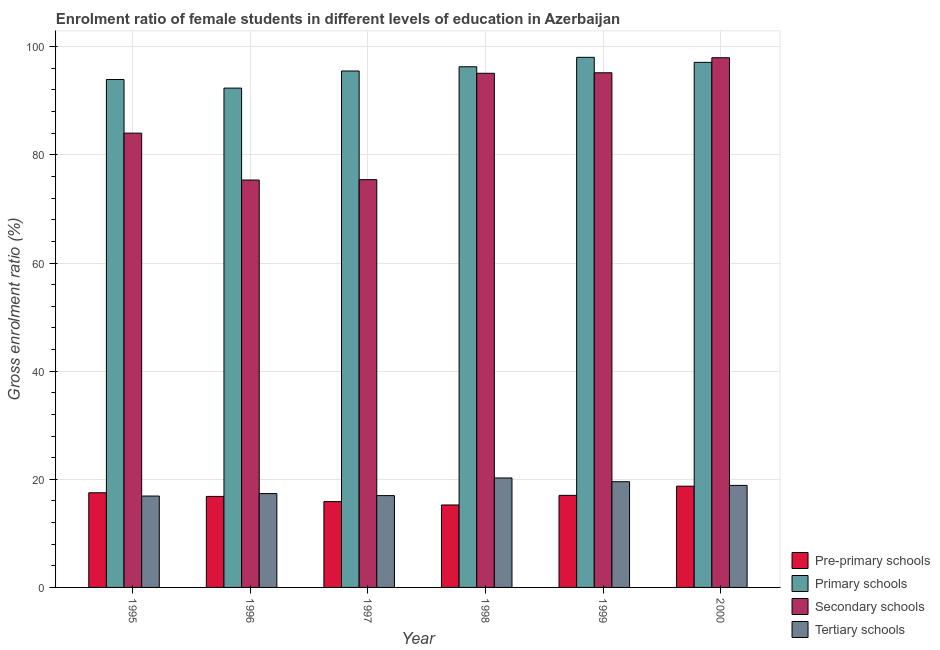How many different coloured bars are there?
Ensure brevity in your answer.  4. Are the number of bars per tick equal to the number of legend labels?
Keep it short and to the point. Yes. Are the number of bars on each tick of the X-axis equal?
Offer a terse response. Yes. How many bars are there on the 3rd tick from the right?
Give a very brief answer. 4. What is the gross enrolment ratio(male) in tertiary schools in 1996?
Provide a short and direct response. 17.35. Across all years, what is the maximum gross enrolment ratio(male) in pre-primary schools?
Ensure brevity in your answer.  18.72. Across all years, what is the minimum gross enrolment ratio(male) in pre-primary schools?
Offer a terse response. 15.25. In which year was the gross enrolment ratio(male) in tertiary schools maximum?
Provide a succinct answer. 1998. In which year was the gross enrolment ratio(male) in primary schools minimum?
Provide a short and direct response. 1996. What is the total gross enrolment ratio(male) in tertiary schools in the graph?
Ensure brevity in your answer.  109.9. What is the difference between the gross enrolment ratio(male) in secondary schools in 1996 and that in 1998?
Provide a short and direct response. -19.74. What is the difference between the gross enrolment ratio(male) in tertiary schools in 1998 and the gross enrolment ratio(male) in secondary schools in 1996?
Make the answer very short. 2.89. What is the average gross enrolment ratio(male) in pre-primary schools per year?
Your answer should be very brief. 16.87. In the year 1997, what is the difference between the gross enrolment ratio(male) in pre-primary schools and gross enrolment ratio(male) in primary schools?
Offer a terse response. 0. What is the ratio of the gross enrolment ratio(male) in secondary schools in 1998 to that in 1999?
Give a very brief answer. 1. Is the difference between the gross enrolment ratio(male) in secondary schools in 1995 and 2000 greater than the difference between the gross enrolment ratio(male) in primary schools in 1995 and 2000?
Your answer should be very brief. No. What is the difference between the highest and the second highest gross enrolment ratio(male) in primary schools?
Ensure brevity in your answer.  0.93. What is the difference between the highest and the lowest gross enrolment ratio(male) in secondary schools?
Offer a very short reply. 22.62. Is the sum of the gross enrolment ratio(male) in primary schools in 1995 and 2000 greater than the maximum gross enrolment ratio(male) in pre-primary schools across all years?
Offer a terse response. Yes. What does the 3rd bar from the left in 1997 represents?
Give a very brief answer. Secondary schools. What does the 3rd bar from the right in 2000 represents?
Your response must be concise. Primary schools. How many years are there in the graph?
Provide a succinct answer. 6. What is the difference between two consecutive major ticks on the Y-axis?
Offer a terse response. 20. Does the graph contain grids?
Ensure brevity in your answer.  Yes. Where does the legend appear in the graph?
Your answer should be compact. Bottom right. How many legend labels are there?
Offer a terse response. 4. How are the legend labels stacked?
Make the answer very short. Vertical. What is the title of the graph?
Your response must be concise. Enrolment ratio of female students in different levels of education in Azerbaijan. Does "Self-employed" appear as one of the legend labels in the graph?
Offer a terse response. No. What is the Gross enrolment ratio (%) of Pre-primary schools in 1995?
Your answer should be very brief. 17.51. What is the Gross enrolment ratio (%) in Primary schools in 1995?
Your answer should be compact. 93.93. What is the Gross enrolment ratio (%) of Secondary schools in 1995?
Provide a succinct answer. 84.02. What is the Gross enrolment ratio (%) in Tertiary schools in 1995?
Offer a terse response. 16.9. What is the Gross enrolment ratio (%) of Pre-primary schools in 1996?
Your answer should be very brief. 16.83. What is the Gross enrolment ratio (%) of Primary schools in 1996?
Offer a terse response. 92.35. What is the Gross enrolment ratio (%) in Secondary schools in 1996?
Offer a terse response. 75.35. What is the Gross enrolment ratio (%) of Tertiary schools in 1996?
Provide a short and direct response. 17.35. What is the Gross enrolment ratio (%) in Pre-primary schools in 1997?
Offer a terse response. 15.87. What is the Gross enrolment ratio (%) of Primary schools in 1997?
Keep it short and to the point. 95.51. What is the Gross enrolment ratio (%) of Secondary schools in 1997?
Make the answer very short. 75.41. What is the Gross enrolment ratio (%) of Tertiary schools in 1997?
Offer a very short reply. 16.98. What is the Gross enrolment ratio (%) of Pre-primary schools in 1998?
Your answer should be very brief. 15.25. What is the Gross enrolment ratio (%) in Primary schools in 1998?
Give a very brief answer. 96.29. What is the Gross enrolment ratio (%) in Secondary schools in 1998?
Provide a short and direct response. 95.09. What is the Gross enrolment ratio (%) in Tertiary schools in 1998?
Your response must be concise. 20.25. What is the Gross enrolment ratio (%) in Pre-primary schools in 1999?
Your answer should be very brief. 17.02. What is the Gross enrolment ratio (%) in Primary schools in 1999?
Ensure brevity in your answer.  98.04. What is the Gross enrolment ratio (%) in Secondary schools in 1999?
Ensure brevity in your answer.  95.18. What is the Gross enrolment ratio (%) in Tertiary schools in 1999?
Give a very brief answer. 19.55. What is the Gross enrolment ratio (%) in Pre-primary schools in 2000?
Provide a succinct answer. 18.72. What is the Gross enrolment ratio (%) of Primary schools in 2000?
Make the answer very short. 97.11. What is the Gross enrolment ratio (%) of Secondary schools in 2000?
Ensure brevity in your answer.  97.96. What is the Gross enrolment ratio (%) of Tertiary schools in 2000?
Give a very brief answer. 18.87. Across all years, what is the maximum Gross enrolment ratio (%) in Pre-primary schools?
Make the answer very short. 18.72. Across all years, what is the maximum Gross enrolment ratio (%) of Primary schools?
Your response must be concise. 98.04. Across all years, what is the maximum Gross enrolment ratio (%) of Secondary schools?
Provide a succinct answer. 97.96. Across all years, what is the maximum Gross enrolment ratio (%) of Tertiary schools?
Provide a succinct answer. 20.25. Across all years, what is the minimum Gross enrolment ratio (%) of Pre-primary schools?
Keep it short and to the point. 15.25. Across all years, what is the minimum Gross enrolment ratio (%) of Primary schools?
Provide a succinct answer. 92.35. Across all years, what is the minimum Gross enrolment ratio (%) in Secondary schools?
Provide a short and direct response. 75.35. Across all years, what is the minimum Gross enrolment ratio (%) in Tertiary schools?
Your answer should be compact. 16.9. What is the total Gross enrolment ratio (%) in Pre-primary schools in the graph?
Make the answer very short. 101.21. What is the total Gross enrolment ratio (%) of Primary schools in the graph?
Make the answer very short. 573.23. What is the total Gross enrolment ratio (%) of Secondary schools in the graph?
Your response must be concise. 523.01. What is the total Gross enrolment ratio (%) in Tertiary schools in the graph?
Your answer should be very brief. 109.9. What is the difference between the Gross enrolment ratio (%) of Pre-primary schools in 1995 and that in 1996?
Your response must be concise. 0.68. What is the difference between the Gross enrolment ratio (%) in Primary schools in 1995 and that in 1996?
Give a very brief answer. 1.59. What is the difference between the Gross enrolment ratio (%) of Secondary schools in 1995 and that in 1996?
Provide a succinct answer. 8.67. What is the difference between the Gross enrolment ratio (%) of Tertiary schools in 1995 and that in 1996?
Ensure brevity in your answer.  -0.45. What is the difference between the Gross enrolment ratio (%) in Pre-primary schools in 1995 and that in 1997?
Your answer should be compact. 1.64. What is the difference between the Gross enrolment ratio (%) in Primary schools in 1995 and that in 1997?
Your answer should be compact. -1.58. What is the difference between the Gross enrolment ratio (%) of Secondary schools in 1995 and that in 1997?
Make the answer very short. 8.61. What is the difference between the Gross enrolment ratio (%) in Tertiary schools in 1995 and that in 1997?
Make the answer very short. -0.08. What is the difference between the Gross enrolment ratio (%) in Pre-primary schools in 1995 and that in 1998?
Offer a very short reply. 2.26. What is the difference between the Gross enrolment ratio (%) of Primary schools in 1995 and that in 1998?
Ensure brevity in your answer.  -2.36. What is the difference between the Gross enrolment ratio (%) in Secondary schools in 1995 and that in 1998?
Ensure brevity in your answer.  -11.07. What is the difference between the Gross enrolment ratio (%) in Tertiary schools in 1995 and that in 1998?
Offer a terse response. -3.34. What is the difference between the Gross enrolment ratio (%) in Pre-primary schools in 1995 and that in 1999?
Offer a terse response. 0.48. What is the difference between the Gross enrolment ratio (%) of Primary schools in 1995 and that in 1999?
Give a very brief answer. -4.1. What is the difference between the Gross enrolment ratio (%) in Secondary schools in 1995 and that in 1999?
Ensure brevity in your answer.  -11.16. What is the difference between the Gross enrolment ratio (%) of Tertiary schools in 1995 and that in 1999?
Your response must be concise. -2.65. What is the difference between the Gross enrolment ratio (%) of Pre-primary schools in 1995 and that in 2000?
Your answer should be very brief. -1.22. What is the difference between the Gross enrolment ratio (%) of Primary schools in 1995 and that in 2000?
Provide a short and direct response. -3.17. What is the difference between the Gross enrolment ratio (%) in Secondary schools in 1995 and that in 2000?
Offer a terse response. -13.95. What is the difference between the Gross enrolment ratio (%) in Tertiary schools in 1995 and that in 2000?
Your answer should be compact. -1.97. What is the difference between the Gross enrolment ratio (%) of Pre-primary schools in 1996 and that in 1997?
Offer a terse response. 0.96. What is the difference between the Gross enrolment ratio (%) in Primary schools in 1996 and that in 1997?
Provide a succinct answer. -3.16. What is the difference between the Gross enrolment ratio (%) in Secondary schools in 1996 and that in 1997?
Provide a succinct answer. -0.07. What is the difference between the Gross enrolment ratio (%) in Tertiary schools in 1996 and that in 1997?
Your response must be concise. 0.37. What is the difference between the Gross enrolment ratio (%) in Pre-primary schools in 1996 and that in 1998?
Give a very brief answer. 1.58. What is the difference between the Gross enrolment ratio (%) in Primary schools in 1996 and that in 1998?
Make the answer very short. -3.95. What is the difference between the Gross enrolment ratio (%) in Secondary schools in 1996 and that in 1998?
Your response must be concise. -19.74. What is the difference between the Gross enrolment ratio (%) in Tertiary schools in 1996 and that in 1998?
Make the answer very short. -2.89. What is the difference between the Gross enrolment ratio (%) of Pre-primary schools in 1996 and that in 1999?
Offer a terse response. -0.19. What is the difference between the Gross enrolment ratio (%) in Primary schools in 1996 and that in 1999?
Give a very brief answer. -5.69. What is the difference between the Gross enrolment ratio (%) in Secondary schools in 1996 and that in 1999?
Give a very brief answer. -19.84. What is the difference between the Gross enrolment ratio (%) in Tertiary schools in 1996 and that in 1999?
Provide a succinct answer. -2.2. What is the difference between the Gross enrolment ratio (%) in Pre-primary schools in 1996 and that in 2000?
Your answer should be very brief. -1.89. What is the difference between the Gross enrolment ratio (%) in Primary schools in 1996 and that in 2000?
Provide a short and direct response. -4.76. What is the difference between the Gross enrolment ratio (%) in Secondary schools in 1996 and that in 2000?
Your answer should be compact. -22.62. What is the difference between the Gross enrolment ratio (%) in Tertiary schools in 1996 and that in 2000?
Make the answer very short. -1.52. What is the difference between the Gross enrolment ratio (%) in Pre-primary schools in 1997 and that in 1998?
Provide a succinct answer. 0.62. What is the difference between the Gross enrolment ratio (%) of Primary schools in 1997 and that in 1998?
Your answer should be compact. -0.78. What is the difference between the Gross enrolment ratio (%) of Secondary schools in 1997 and that in 1998?
Make the answer very short. -19.67. What is the difference between the Gross enrolment ratio (%) of Tertiary schools in 1997 and that in 1998?
Make the answer very short. -3.26. What is the difference between the Gross enrolment ratio (%) in Pre-primary schools in 1997 and that in 1999?
Your answer should be compact. -1.15. What is the difference between the Gross enrolment ratio (%) in Primary schools in 1997 and that in 1999?
Keep it short and to the point. -2.53. What is the difference between the Gross enrolment ratio (%) in Secondary schools in 1997 and that in 1999?
Make the answer very short. -19.77. What is the difference between the Gross enrolment ratio (%) of Tertiary schools in 1997 and that in 1999?
Your answer should be very brief. -2.57. What is the difference between the Gross enrolment ratio (%) in Pre-primary schools in 1997 and that in 2000?
Offer a terse response. -2.85. What is the difference between the Gross enrolment ratio (%) in Primary schools in 1997 and that in 2000?
Make the answer very short. -1.6. What is the difference between the Gross enrolment ratio (%) of Secondary schools in 1997 and that in 2000?
Ensure brevity in your answer.  -22.55. What is the difference between the Gross enrolment ratio (%) in Tertiary schools in 1997 and that in 2000?
Your answer should be very brief. -1.89. What is the difference between the Gross enrolment ratio (%) of Pre-primary schools in 1998 and that in 1999?
Offer a very short reply. -1.78. What is the difference between the Gross enrolment ratio (%) of Primary schools in 1998 and that in 1999?
Keep it short and to the point. -1.74. What is the difference between the Gross enrolment ratio (%) in Secondary schools in 1998 and that in 1999?
Give a very brief answer. -0.1. What is the difference between the Gross enrolment ratio (%) of Tertiary schools in 1998 and that in 1999?
Make the answer very short. 0.7. What is the difference between the Gross enrolment ratio (%) in Pre-primary schools in 1998 and that in 2000?
Provide a succinct answer. -3.48. What is the difference between the Gross enrolment ratio (%) in Primary schools in 1998 and that in 2000?
Make the answer very short. -0.81. What is the difference between the Gross enrolment ratio (%) of Secondary schools in 1998 and that in 2000?
Keep it short and to the point. -2.88. What is the difference between the Gross enrolment ratio (%) in Tertiary schools in 1998 and that in 2000?
Provide a succinct answer. 1.38. What is the difference between the Gross enrolment ratio (%) of Pre-primary schools in 1999 and that in 2000?
Ensure brevity in your answer.  -1.7. What is the difference between the Gross enrolment ratio (%) of Secondary schools in 1999 and that in 2000?
Provide a short and direct response. -2.78. What is the difference between the Gross enrolment ratio (%) in Tertiary schools in 1999 and that in 2000?
Offer a very short reply. 0.68. What is the difference between the Gross enrolment ratio (%) of Pre-primary schools in 1995 and the Gross enrolment ratio (%) of Primary schools in 1996?
Offer a very short reply. -74.84. What is the difference between the Gross enrolment ratio (%) of Pre-primary schools in 1995 and the Gross enrolment ratio (%) of Secondary schools in 1996?
Ensure brevity in your answer.  -57.84. What is the difference between the Gross enrolment ratio (%) in Pre-primary schools in 1995 and the Gross enrolment ratio (%) in Tertiary schools in 1996?
Ensure brevity in your answer.  0.15. What is the difference between the Gross enrolment ratio (%) of Primary schools in 1995 and the Gross enrolment ratio (%) of Secondary schools in 1996?
Ensure brevity in your answer.  18.59. What is the difference between the Gross enrolment ratio (%) of Primary schools in 1995 and the Gross enrolment ratio (%) of Tertiary schools in 1996?
Offer a very short reply. 76.58. What is the difference between the Gross enrolment ratio (%) in Secondary schools in 1995 and the Gross enrolment ratio (%) in Tertiary schools in 1996?
Ensure brevity in your answer.  66.67. What is the difference between the Gross enrolment ratio (%) of Pre-primary schools in 1995 and the Gross enrolment ratio (%) of Primary schools in 1997?
Provide a short and direct response. -78. What is the difference between the Gross enrolment ratio (%) of Pre-primary schools in 1995 and the Gross enrolment ratio (%) of Secondary schools in 1997?
Provide a short and direct response. -57.9. What is the difference between the Gross enrolment ratio (%) in Pre-primary schools in 1995 and the Gross enrolment ratio (%) in Tertiary schools in 1997?
Offer a terse response. 0.53. What is the difference between the Gross enrolment ratio (%) of Primary schools in 1995 and the Gross enrolment ratio (%) of Secondary schools in 1997?
Provide a short and direct response. 18.52. What is the difference between the Gross enrolment ratio (%) of Primary schools in 1995 and the Gross enrolment ratio (%) of Tertiary schools in 1997?
Provide a short and direct response. 76.95. What is the difference between the Gross enrolment ratio (%) in Secondary schools in 1995 and the Gross enrolment ratio (%) in Tertiary schools in 1997?
Keep it short and to the point. 67.04. What is the difference between the Gross enrolment ratio (%) in Pre-primary schools in 1995 and the Gross enrolment ratio (%) in Primary schools in 1998?
Give a very brief answer. -78.79. What is the difference between the Gross enrolment ratio (%) in Pre-primary schools in 1995 and the Gross enrolment ratio (%) in Secondary schools in 1998?
Offer a very short reply. -77.58. What is the difference between the Gross enrolment ratio (%) in Pre-primary schools in 1995 and the Gross enrolment ratio (%) in Tertiary schools in 1998?
Offer a terse response. -2.74. What is the difference between the Gross enrolment ratio (%) in Primary schools in 1995 and the Gross enrolment ratio (%) in Secondary schools in 1998?
Offer a terse response. -1.15. What is the difference between the Gross enrolment ratio (%) in Primary schools in 1995 and the Gross enrolment ratio (%) in Tertiary schools in 1998?
Give a very brief answer. 73.69. What is the difference between the Gross enrolment ratio (%) of Secondary schools in 1995 and the Gross enrolment ratio (%) of Tertiary schools in 1998?
Offer a very short reply. 63.77. What is the difference between the Gross enrolment ratio (%) of Pre-primary schools in 1995 and the Gross enrolment ratio (%) of Primary schools in 1999?
Give a very brief answer. -80.53. What is the difference between the Gross enrolment ratio (%) of Pre-primary schools in 1995 and the Gross enrolment ratio (%) of Secondary schools in 1999?
Your response must be concise. -77.67. What is the difference between the Gross enrolment ratio (%) of Pre-primary schools in 1995 and the Gross enrolment ratio (%) of Tertiary schools in 1999?
Keep it short and to the point. -2.04. What is the difference between the Gross enrolment ratio (%) in Primary schools in 1995 and the Gross enrolment ratio (%) in Secondary schools in 1999?
Offer a terse response. -1.25. What is the difference between the Gross enrolment ratio (%) in Primary schools in 1995 and the Gross enrolment ratio (%) in Tertiary schools in 1999?
Offer a very short reply. 74.38. What is the difference between the Gross enrolment ratio (%) of Secondary schools in 1995 and the Gross enrolment ratio (%) of Tertiary schools in 1999?
Offer a terse response. 64.47. What is the difference between the Gross enrolment ratio (%) in Pre-primary schools in 1995 and the Gross enrolment ratio (%) in Primary schools in 2000?
Provide a succinct answer. -79.6. What is the difference between the Gross enrolment ratio (%) in Pre-primary schools in 1995 and the Gross enrolment ratio (%) in Secondary schools in 2000?
Offer a very short reply. -80.46. What is the difference between the Gross enrolment ratio (%) of Pre-primary schools in 1995 and the Gross enrolment ratio (%) of Tertiary schools in 2000?
Your answer should be very brief. -1.36. What is the difference between the Gross enrolment ratio (%) in Primary schools in 1995 and the Gross enrolment ratio (%) in Secondary schools in 2000?
Make the answer very short. -4.03. What is the difference between the Gross enrolment ratio (%) in Primary schools in 1995 and the Gross enrolment ratio (%) in Tertiary schools in 2000?
Your answer should be compact. 75.06. What is the difference between the Gross enrolment ratio (%) in Secondary schools in 1995 and the Gross enrolment ratio (%) in Tertiary schools in 2000?
Make the answer very short. 65.15. What is the difference between the Gross enrolment ratio (%) of Pre-primary schools in 1996 and the Gross enrolment ratio (%) of Primary schools in 1997?
Your response must be concise. -78.68. What is the difference between the Gross enrolment ratio (%) of Pre-primary schools in 1996 and the Gross enrolment ratio (%) of Secondary schools in 1997?
Your answer should be compact. -58.58. What is the difference between the Gross enrolment ratio (%) of Pre-primary schools in 1996 and the Gross enrolment ratio (%) of Tertiary schools in 1997?
Your response must be concise. -0.15. What is the difference between the Gross enrolment ratio (%) of Primary schools in 1996 and the Gross enrolment ratio (%) of Secondary schools in 1997?
Offer a very short reply. 16.94. What is the difference between the Gross enrolment ratio (%) of Primary schools in 1996 and the Gross enrolment ratio (%) of Tertiary schools in 1997?
Your answer should be very brief. 75.37. What is the difference between the Gross enrolment ratio (%) in Secondary schools in 1996 and the Gross enrolment ratio (%) in Tertiary schools in 1997?
Offer a very short reply. 58.36. What is the difference between the Gross enrolment ratio (%) of Pre-primary schools in 1996 and the Gross enrolment ratio (%) of Primary schools in 1998?
Give a very brief answer. -79.46. What is the difference between the Gross enrolment ratio (%) of Pre-primary schools in 1996 and the Gross enrolment ratio (%) of Secondary schools in 1998?
Give a very brief answer. -78.25. What is the difference between the Gross enrolment ratio (%) in Pre-primary schools in 1996 and the Gross enrolment ratio (%) in Tertiary schools in 1998?
Provide a succinct answer. -3.41. What is the difference between the Gross enrolment ratio (%) of Primary schools in 1996 and the Gross enrolment ratio (%) of Secondary schools in 1998?
Your response must be concise. -2.74. What is the difference between the Gross enrolment ratio (%) in Primary schools in 1996 and the Gross enrolment ratio (%) in Tertiary schools in 1998?
Provide a short and direct response. 72.1. What is the difference between the Gross enrolment ratio (%) of Secondary schools in 1996 and the Gross enrolment ratio (%) of Tertiary schools in 1998?
Your response must be concise. 55.1. What is the difference between the Gross enrolment ratio (%) of Pre-primary schools in 1996 and the Gross enrolment ratio (%) of Primary schools in 1999?
Provide a short and direct response. -81.21. What is the difference between the Gross enrolment ratio (%) in Pre-primary schools in 1996 and the Gross enrolment ratio (%) in Secondary schools in 1999?
Your response must be concise. -78.35. What is the difference between the Gross enrolment ratio (%) of Pre-primary schools in 1996 and the Gross enrolment ratio (%) of Tertiary schools in 1999?
Your response must be concise. -2.72. What is the difference between the Gross enrolment ratio (%) in Primary schools in 1996 and the Gross enrolment ratio (%) in Secondary schools in 1999?
Your response must be concise. -2.83. What is the difference between the Gross enrolment ratio (%) in Primary schools in 1996 and the Gross enrolment ratio (%) in Tertiary schools in 1999?
Your answer should be very brief. 72.8. What is the difference between the Gross enrolment ratio (%) in Secondary schools in 1996 and the Gross enrolment ratio (%) in Tertiary schools in 1999?
Make the answer very short. 55.8. What is the difference between the Gross enrolment ratio (%) of Pre-primary schools in 1996 and the Gross enrolment ratio (%) of Primary schools in 2000?
Keep it short and to the point. -80.28. What is the difference between the Gross enrolment ratio (%) of Pre-primary schools in 1996 and the Gross enrolment ratio (%) of Secondary schools in 2000?
Offer a terse response. -81.13. What is the difference between the Gross enrolment ratio (%) of Pre-primary schools in 1996 and the Gross enrolment ratio (%) of Tertiary schools in 2000?
Provide a succinct answer. -2.04. What is the difference between the Gross enrolment ratio (%) in Primary schools in 1996 and the Gross enrolment ratio (%) in Secondary schools in 2000?
Provide a succinct answer. -5.62. What is the difference between the Gross enrolment ratio (%) of Primary schools in 1996 and the Gross enrolment ratio (%) of Tertiary schools in 2000?
Offer a terse response. 73.48. What is the difference between the Gross enrolment ratio (%) in Secondary schools in 1996 and the Gross enrolment ratio (%) in Tertiary schools in 2000?
Your response must be concise. 56.48. What is the difference between the Gross enrolment ratio (%) of Pre-primary schools in 1997 and the Gross enrolment ratio (%) of Primary schools in 1998?
Ensure brevity in your answer.  -80.42. What is the difference between the Gross enrolment ratio (%) of Pre-primary schools in 1997 and the Gross enrolment ratio (%) of Secondary schools in 1998?
Keep it short and to the point. -79.21. What is the difference between the Gross enrolment ratio (%) in Pre-primary schools in 1997 and the Gross enrolment ratio (%) in Tertiary schools in 1998?
Offer a very short reply. -4.37. What is the difference between the Gross enrolment ratio (%) of Primary schools in 1997 and the Gross enrolment ratio (%) of Secondary schools in 1998?
Offer a very short reply. 0.43. What is the difference between the Gross enrolment ratio (%) of Primary schools in 1997 and the Gross enrolment ratio (%) of Tertiary schools in 1998?
Your answer should be compact. 75.27. What is the difference between the Gross enrolment ratio (%) in Secondary schools in 1997 and the Gross enrolment ratio (%) in Tertiary schools in 1998?
Ensure brevity in your answer.  55.17. What is the difference between the Gross enrolment ratio (%) in Pre-primary schools in 1997 and the Gross enrolment ratio (%) in Primary schools in 1999?
Offer a very short reply. -82.17. What is the difference between the Gross enrolment ratio (%) of Pre-primary schools in 1997 and the Gross enrolment ratio (%) of Secondary schools in 1999?
Provide a short and direct response. -79.31. What is the difference between the Gross enrolment ratio (%) in Pre-primary schools in 1997 and the Gross enrolment ratio (%) in Tertiary schools in 1999?
Make the answer very short. -3.68. What is the difference between the Gross enrolment ratio (%) in Primary schools in 1997 and the Gross enrolment ratio (%) in Secondary schools in 1999?
Offer a very short reply. 0.33. What is the difference between the Gross enrolment ratio (%) in Primary schools in 1997 and the Gross enrolment ratio (%) in Tertiary schools in 1999?
Your answer should be compact. 75.96. What is the difference between the Gross enrolment ratio (%) in Secondary schools in 1997 and the Gross enrolment ratio (%) in Tertiary schools in 1999?
Ensure brevity in your answer.  55.86. What is the difference between the Gross enrolment ratio (%) in Pre-primary schools in 1997 and the Gross enrolment ratio (%) in Primary schools in 2000?
Provide a succinct answer. -81.24. What is the difference between the Gross enrolment ratio (%) in Pre-primary schools in 1997 and the Gross enrolment ratio (%) in Secondary schools in 2000?
Make the answer very short. -82.09. What is the difference between the Gross enrolment ratio (%) of Pre-primary schools in 1997 and the Gross enrolment ratio (%) of Tertiary schools in 2000?
Your answer should be compact. -3. What is the difference between the Gross enrolment ratio (%) of Primary schools in 1997 and the Gross enrolment ratio (%) of Secondary schools in 2000?
Offer a terse response. -2.45. What is the difference between the Gross enrolment ratio (%) in Primary schools in 1997 and the Gross enrolment ratio (%) in Tertiary schools in 2000?
Provide a short and direct response. 76.64. What is the difference between the Gross enrolment ratio (%) in Secondary schools in 1997 and the Gross enrolment ratio (%) in Tertiary schools in 2000?
Offer a terse response. 56.54. What is the difference between the Gross enrolment ratio (%) in Pre-primary schools in 1998 and the Gross enrolment ratio (%) in Primary schools in 1999?
Ensure brevity in your answer.  -82.79. What is the difference between the Gross enrolment ratio (%) in Pre-primary schools in 1998 and the Gross enrolment ratio (%) in Secondary schools in 1999?
Offer a terse response. -79.93. What is the difference between the Gross enrolment ratio (%) in Pre-primary schools in 1998 and the Gross enrolment ratio (%) in Tertiary schools in 1999?
Offer a terse response. -4.3. What is the difference between the Gross enrolment ratio (%) in Primary schools in 1998 and the Gross enrolment ratio (%) in Secondary schools in 1999?
Keep it short and to the point. 1.11. What is the difference between the Gross enrolment ratio (%) of Primary schools in 1998 and the Gross enrolment ratio (%) of Tertiary schools in 1999?
Provide a succinct answer. 76.74. What is the difference between the Gross enrolment ratio (%) of Secondary schools in 1998 and the Gross enrolment ratio (%) of Tertiary schools in 1999?
Offer a very short reply. 75.53. What is the difference between the Gross enrolment ratio (%) in Pre-primary schools in 1998 and the Gross enrolment ratio (%) in Primary schools in 2000?
Give a very brief answer. -81.86. What is the difference between the Gross enrolment ratio (%) of Pre-primary schools in 1998 and the Gross enrolment ratio (%) of Secondary schools in 2000?
Make the answer very short. -82.72. What is the difference between the Gross enrolment ratio (%) of Pre-primary schools in 1998 and the Gross enrolment ratio (%) of Tertiary schools in 2000?
Make the answer very short. -3.62. What is the difference between the Gross enrolment ratio (%) in Primary schools in 1998 and the Gross enrolment ratio (%) in Secondary schools in 2000?
Provide a succinct answer. -1.67. What is the difference between the Gross enrolment ratio (%) of Primary schools in 1998 and the Gross enrolment ratio (%) of Tertiary schools in 2000?
Your answer should be compact. 77.42. What is the difference between the Gross enrolment ratio (%) of Secondary schools in 1998 and the Gross enrolment ratio (%) of Tertiary schools in 2000?
Your response must be concise. 76.21. What is the difference between the Gross enrolment ratio (%) in Pre-primary schools in 1999 and the Gross enrolment ratio (%) in Primary schools in 2000?
Make the answer very short. -80.08. What is the difference between the Gross enrolment ratio (%) in Pre-primary schools in 1999 and the Gross enrolment ratio (%) in Secondary schools in 2000?
Provide a succinct answer. -80.94. What is the difference between the Gross enrolment ratio (%) in Pre-primary schools in 1999 and the Gross enrolment ratio (%) in Tertiary schools in 2000?
Offer a terse response. -1.85. What is the difference between the Gross enrolment ratio (%) of Primary schools in 1999 and the Gross enrolment ratio (%) of Secondary schools in 2000?
Your answer should be very brief. 0.07. What is the difference between the Gross enrolment ratio (%) of Primary schools in 1999 and the Gross enrolment ratio (%) of Tertiary schools in 2000?
Give a very brief answer. 79.17. What is the difference between the Gross enrolment ratio (%) in Secondary schools in 1999 and the Gross enrolment ratio (%) in Tertiary schools in 2000?
Make the answer very short. 76.31. What is the average Gross enrolment ratio (%) of Pre-primary schools per year?
Your answer should be compact. 16.87. What is the average Gross enrolment ratio (%) of Primary schools per year?
Provide a succinct answer. 95.54. What is the average Gross enrolment ratio (%) in Secondary schools per year?
Ensure brevity in your answer.  87.17. What is the average Gross enrolment ratio (%) of Tertiary schools per year?
Ensure brevity in your answer.  18.32. In the year 1995, what is the difference between the Gross enrolment ratio (%) in Pre-primary schools and Gross enrolment ratio (%) in Primary schools?
Ensure brevity in your answer.  -76.42. In the year 1995, what is the difference between the Gross enrolment ratio (%) in Pre-primary schools and Gross enrolment ratio (%) in Secondary schools?
Make the answer very short. -66.51. In the year 1995, what is the difference between the Gross enrolment ratio (%) in Pre-primary schools and Gross enrolment ratio (%) in Tertiary schools?
Offer a very short reply. 0.61. In the year 1995, what is the difference between the Gross enrolment ratio (%) in Primary schools and Gross enrolment ratio (%) in Secondary schools?
Your answer should be compact. 9.91. In the year 1995, what is the difference between the Gross enrolment ratio (%) of Primary schools and Gross enrolment ratio (%) of Tertiary schools?
Give a very brief answer. 77.03. In the year 1995, what is the difference between the Gross enrolment ratio (%) in Secondary schools and Gross enrolment ratio (%) in Tertiary schools?
Provide a short and direct response. 67.12. In the year 1996, what is the difference between the Gross enrolment ratio (%) in Pre-primary schools and Gross enrolment ratio (%) in Primary schools?
Your answer should be very brief. -75.52. In the year 1996, what is the difference between the Gross enrolment ratio (%) in Pre-primary schools and Gross enrolment ratio (%) in Secondary schools?
Your answer should be compact. -58.51. In the year 1996, what is the difference between the Gross enrolment ratio (%) of Pre-primary schools and Gross enrolment ratio (%) of Tertiary schools?
Ensure brevity in your answer.  -0.52. In the year 1996, what is the difference between the Gross enrolment ratio (%) in Primary schools and Gross enrolment ratio (%) in Secondary schools?
Make the answer very short. 17. In the year 1996, what is the difference between the Gross enrolment ratio (%) in Primary schools and Gross enrolment ratio (%) in Tertiary schools?
Keep it short and to the point. 74.99. In the year 1996, what is the difference between the Gross enrolment ratio (%) in Secondary schools and Gross enrolment ratio (%) in Tertiary schools?
Your answer should be compact. 57.99. In the year 1997, what is the difference between the Gross enrolment ratio (%) of Pre-primary schools and Gross enrolment ratio (%) of Primary schools?
Keep it short and to the point. -79.64. In the year 1997, what is the difference between the Gross enrolment ratio (%) in Pre-primary schools and Gross enrolment ratio (%) in Secondary schools?
Your answer should be very brief. -59.54. In the year 1997, what is the difference between the Gross enrolment ratio (%) in Pre-primary schools and Gross enrolment ratio (%) in Tertiary schools?
Your answer should be compact. -1.11. In the year 1997, what is the difference between the Gross enrolment ratio (%) in Primary schools and Gross enrolment ratio (%) in Secondary schools?
Keep it short and to the point. 20.1. In the year 1997, what is the difference between the Gross enrolment ratio (%) in Primary schools and Gross enrolment ratio (%) in Tertiary schools?
Keep it short and to the point. 78.53. In the year 1997, what is the difference between the Gross enrolment ratio (%) in Secondary schools and Gross enrolment ratio (%) in Tertiary schools?
Your response must be concise. 58.43. In the year 1998, what is the difference between the Gross enrolment ratio (%) in Pre-primary schools and Gross enrolment ratio (%) in Primary schools?
Make the answer very short. -81.05. In the year 1998, what is the difference between the Gross enrolment ratio (%) in Pre-primary schools and Gross enrolment ratio (%) in Secondary schools?
Provide a succinct answer. -79.84. In the year 1998, what is the difference between the Gross enrolment ratio (%) in Pre-primary schools and Gross enrolment ratio (%) in Tertiary schools?
Make the answer very short. -5. In the year 1998, what is the difference between the Gross enrolment ratio (%) in Primary schools and Gross enrolment ratio (%) in Secondary schools?
Give a very brief answer. 1.21. In the year 1998, what is the difference between the Gross enrolment ratio (%) of Primary schools and Gross enrolment ratio (%) of Tertiary schools?
Provide a succinct answer. 76.05. In the year 1998, what is the difference between the Gross enrolment ratio (%) in Secondary schools and Gross enrolment ratio (%) in Tertiary schools?
Offer a terse response. 74.84. In the year 1999, what is the difference between the Gross enrolment ratio (%) in Pre-primary schools and Gross enrolment ratio (%) in Primary schools?
Offer a terse response. -81.01. In the year 1999, what is the difference between the Gross enrolment ratio (%) in Pre-primary schools and Gross enrolment ratio (%) in Secondary schools?
Provide a short and direct response. -78.16. In the year 1999, what is the difference between the Gross enrolment ratio (%) of Pre-primary schools and Gross enrolment ratio (%) of Tertiary schools?
Provide a succinct answer. -2.53. In the year 1999, what is the difference between the Gross enrolment ratio (%) of Primary schools and Gross enrolment ratio (%) of Secondary schools?
Offer a very short reply. 2.86. In the year 1999, what is the difference between the Gross enrolment ratio (%) of Primary schools and Gross enrolment ratio (%) of Tertiary schools?
Keep it short and to the point. 78.49. In the year 1999, what is the difference between the Gross enrolment ratio (%) of Secondary schools and Gross enrolment ratio (%) of Tertiary schools?
Your response must be concise. 75.63. In the year 2000, what is the difference between the Gross enrolment ratio (%) in Pre-primary schools and Gross enrolment ratio (%) in Primary schools?
Provide a short and direct response. -78.38. In the year 2000, what is the difference between the Gross enrolment ratio (%) in Pre-primary schools and Gross enrolment ratio (%) in Secondary schools?
Your answer should be very brief. -79.24. In the year 2000, what is the difference between the Gross enrolment ratio (%) of Pre-primary schools and Gross enrolment ratio (%) of Tertiary schools?
Provide a short and direct response. -0.15. In the year 2000, what is the difference between the Gross enrolment ratio (%) in Primary schools and Gross enrolment ratio (%) in Secondary schools?
Your answer should be compact. -0.86. In the year 2000, what is the difference between the Gross enrolment ratio (%) in Primary schools and Gross enrolment ratio (%) in Tertiary schools?
Your response must be concise. 78.24. In the year 2000, what is the difference between the Gross enrolment ratio (%) in Secondary schools and Gross enrolment ratio (%) in Tertiary schools?
Keep it short and to the point. 79.09. What is the ratio of the Gross enrolment ratio (%) of Pre-primary schools in 1995 to that in 1996?
Offer a terse response. 1.04. What is the ratio of the Gross enrolment ratio (%) of Primary schools in 1995 to that in 1996?
Offer a very short reply. 1.02. What is the ratio of the Gross enrolment ratio (%) of Secondary schools in 1995 to that in 1996?
Ensure brevity in your answer.  1.12. What is the ratio of the Gross enrolment ratio (%) of Tertiary schools in 1995 to that in 1996?
Give a very brief answer. 0.97. What is the ratio of the Gross enrolment ratio (%) in Pre-primary schools in 1995 to that in 1997?
Keep it short and to the point. 1.1. What is the ratio of the Gross enrolment ratio (%) of Primary schools in 1995 to that in 1997?
Provide a succinct answer. 0.98. What is the ratio of the Gross enrolment ratio (%) in Secondary schools in 1995 to that in 1997?
Keep it short and to the point. 1.11. What is the ratio of the Gross enrolment ratio (%) in Tertiary schools in 1995 to that in 1997?
Keep it short and to the point. 1. What is the ratio of the Gross enrolment ratio (%) in Pre-primary schools in 1995 to that in 1998?
Make the answer very short. 1.15. What is the ratio of the Gross enrolment ratio (%) of Primary schools in 1995 to that in 1998?
Provide a short and direct response. 0.98. What is the ratio of the Gross enrolment ratio (%) in Secondary schools in 1995 to that in 1998?
Offer a terse response. 0.88. What is the ratio of the Gross enrolment ratio (%) in Tertiary schools in 1995 to that in 1998?
Provide a short and direct response. 0.83. What is the ratio of the Gross enrolment ratio (%) of Pre-primary schools in 1995 to that in 1999?
Offer a very short reply. 1.03. What is the ratio of the Gross enrolment ratio (%) of Primary schools in 1995 to that in 1999?
Your answer should be very brief. 0.96. What is the ratio of the Gross enrolment ratio (%) in Secondary schools in 1995 to that in 1999?
Give a very brief answer. 0.88. What is the ratio of the Gross enrolment ratio (%) of Tertiary schools in 1995 to that in 1999?
Keep it short and to the point. 0.86. What is the ratio of the Gross enrolment ratio (%) of Pre-primary schools in 1995 to that in 2000?
Provide a succinct answer. 0.94. What is the ratio of the Gross enrolment ratio (%) of Primary schools in 1995 to that in 2000?
Offer a terse response. 0.97. What is the ratio of the Gross enrolment ratio (%) of Secondary schools in 1995 to that in 2000?
Make the answer very short. 0.86. What is the ratio of the Gross enrolment ratio (%) of Tertiary schools in 1995 to that in 2000?
Give a very brief answer. 0.9. What is the ratio of the Gross enrolment ratio (%) of Pre-primary schools in 1996 to that in 1997?
Provide a succinct answer. 1.06. What is the ratio of the Gross enrolment ratio (%) in Primary schools in 1996 to that in 1997?
Your answer should be very brief. 0.97. What is the ratio of the Gross enrolment ratio (%) of Pre-primary schools in 1996 to that in 1998?
Keep it short and to the point. 1.1. What is the ratio of the Gross enrolment ratio (%) in Secondary schools in 1996 to that in 1998?
Provide a succinct answer. 0.79. What is the ratio of the Gross enrolment ratio (%) of Tertiary schools in 1996 to that in 1998?
Ensure brevity in your answer.  0.86. What is the ratio of the Gross enrolment ratio (%) of Pre-primary schools in 1996 to that in 1999?
Offer a terse response. 0.99. What is the ratio of the Gross enrolment ratio (%) of Primary schools in 1996 to that in 1999?
Provide a succinct answer. 0.94. What is the ratio of the Gross enrolment ratio (%) of Secondary schools in 1996 to that in 1999?
Your answer should be very brief. 0.79. What is the ratio of the Gross enrolment ratio (%) of Tertiary schools in 1996 to that in 1999?
Provide a succinct answer. 0.89. What is the ratio of the Gross enrolment ratio (%) in Pre-primary schools in 1996 to that in 2000?
Your answer should be compact. 0.9. What is the ratio of the Gross enrolment ratio (%) in Primary schools in 1996 to that in 2000?
Ensure brevity in your answer.  0.95. What is the ratio of the Gross enrolment ratio (%) of Secondary schools in 1996 to that in 2000?
Offer a very short reply. 0.77. What is the ratio of the Gross enrolment ratio (%) in Tertiary schools in 1996 to that in 2000?
Provide a succinct answer. 0.92. What is the ratio of the Gross enrolment ratio (%) of Pre-primary schools in 1997 to that in 1998?
Give a very brief answer. 1.04. What is the ratio of the Gross enrolment ratio (%) in Secondary schools in 1997 to that in 1998?
Offer a very short reply. 0.79. What is the ratio of the Gross enrolment ratio (%) in Tertiary schools in 1997 to that in 1998?
Provide a succinct answer. 0.84. What is the ratio of the Gross enrolment ratio (%) of Pre-primary schools in 1997 to that in 1999?
Your response must be concise. 0.93. What is the ratio of the Gross enrolment ratio (%) in Primary schools in 1997 to that in 1999?
Your response must be concise. 0.97. What is the ratio of the Gross enrolment ratio (%) of Secondary schools in 1997 to that in 1999?
Give a very brief answer. 0.79. What is the ratio of the Gross enrolment ratio (%) in Tertiary schools in 1997 to that in 1999?
Keep it short and to the point. 0.87. What is the ratio of the Gross enrolment ratio (%) in Pre-primary schools in 1997 to that in 2000?
Provide a succinct answer. 0.85. What is the ratio of the Gross enrolment ratio (%) in Primary schools in 1997 to that in 2000?
Your response must be concise. 0.98. What is the ratio of the Gross enrolment ratio (%) of Secondary schools in 1997 to that in 2000?
Keep it short and to the point. 0.77. What is the ratio of the Gross enrolment ratio (%) of Tertiary schools in 1997 to that in 2000?
Give a very brief answer. 0.9. What is the ratio of the Gross enrolment ratio (%) of Pre-primary schools in 1998 to that in 1999?
Your answer should be very brief. 0.9. What is the ratio of the Gross enrolment ratio (%) in Primary schools in 1998 to that in 1999?
Ensure brevity in your answer.  0.98. What is the ratio of the Gross enrolment ratio (%) in Secondary schools in 1998 to that in 1999?
Your answer should be compact. 1. What is the ratio of the Gross enrolment ratio (%) in Tertiary schools in 1998 to that in 1999?
Ensure brevity in your answer.  1.04. What is the ratio of the Gross enrolment ratio (%) in Pre-primary schools in 1998 to that in 2000?
Offer a very short reply. 0.81. What is the ratio of the Gross enrolment ratio (%) in Secondary schools in 1998 to that in 2000?
Keep it short and to the point. 0.97. What is the ratio of the Gross enrolment ratio (%) of Tertiary schools in 1998 to that in 2000?
Your answer should be compact. 1.07. What is the ratio of the Gross enrolment ratio (%) of Pre-primary schools in 1999 to that in 2000?
Offer a very short reply. 0.91. What is the ratio of the Gross enrolment ratio (%) of Primary schools in 1999 to that in 2000?
Ensure brevity in your answer.  1.01. What is the ratio of the Gross enrolment ratio (%) in Secondary schools in 1999 to that in 2000?
Your answer should be compact. 0.97. What is the ratio of the Gross enrolment ratio (%) in Tertiary schools in 1999 to that in 2000?
Provide a short and direct response. 1.04. What is the difference between the highest and the second highest Gross enrolment ratio (%) in Pre-primary schools?
Ensure brevity in your answer.  1.22. What is the difference between the highest and the second highest Gross enrolment ratio (%) of Secondary schools?
Provide a short and direct response. 2.78. What is the difference between the highest and the second highest Gross enrolment ratio (%) of Tertiary schools?
Your answer should be compact. 0.7. What is the difference between the highest and the lowest Gross enrolment ratio (%) of Pre-primary schools?
Your answer should be very brief. 3.48. What is the difference between the highest and the lowest Gross enrolment ratio (%) of Primary schools?
Your answer should be compact. 5.69. What is the difference between the highest and the lowest Gross enrolment ratio (%) in Secondary schools?
Give a very brief answer. 22.62. What is the difference between the highest and the lowest Gross enrolment ratio (%) of Tertiary schools?
Provide a short and direct response. 3.34. 